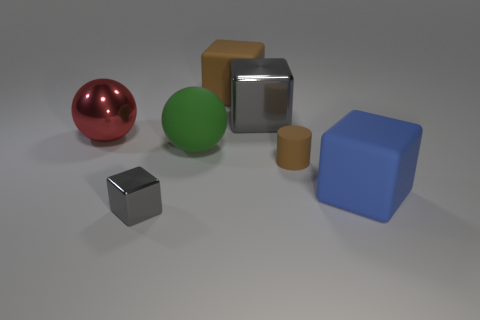There is a ball left of the gray object that is in front of the large red shiny thing; what is its size?
Your response must be concise. Large. Are there the same number of large brown blocks that are in front of the tiny metallic object and large rubber cubes left of the brown rubber block?
Give a very brief answer. Yes. The thing that is to the left of the large rubber sphere and behind the tiny brown cylinder is made of what material?
Make the answer very short. Metal. There is a green matte ball; is its size the same as the matte block that is on the right side of the large brown block?
Your response must be concise. Yes. How many other things are there of the same color as the cylinder?
Provide a short and direct response. 1. Is the number of matte balls to the left of the large green object greater than the number of large green balls?
Your answer should be compact. No. The big matte block in front of the gray object behind the gray block that is in front of the large red shiny sphere is what color?
Your answer should be compact. Blue. Is the material of the big green thing the same as the tiny gray object?
Your answer should be compact. No. Are there any red metal things of the same size as the rubber sphere?
Ensure brevity in your answer.  Yes. What material is the brown thing that is the same size as the red thing?
Offer a very short reply. Rubber. 